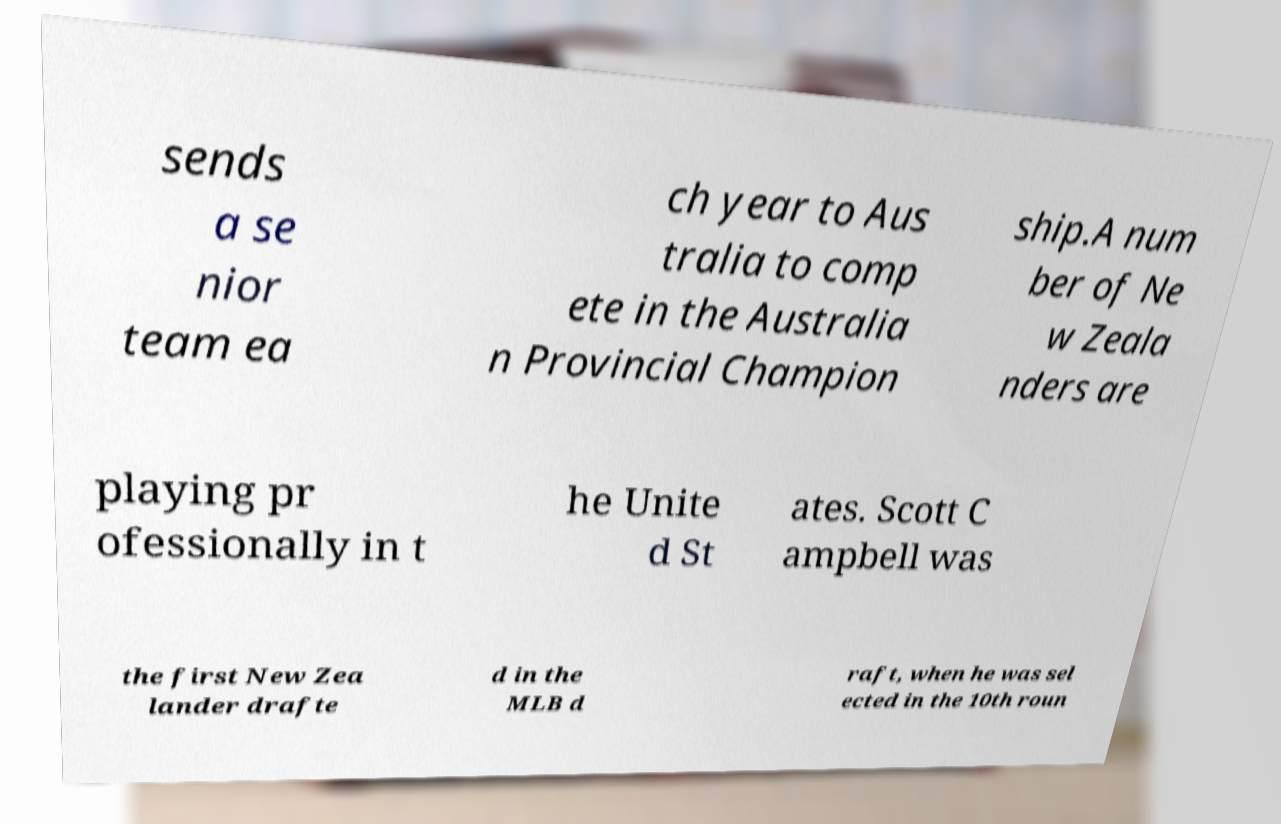Please read and relay the text visible in this image. What does it say? sends a se nior team ea ch year to Aus tralia to comp ete in the Australia n Provincial Champion ship.A num ber of Ne w Zeala nders are playing pr ofessionally in t he Unite d St ates. Scott C ampbell was the first New Zea lander drafte d in the MLB d raft, when he was sel ected in the 10th roun 